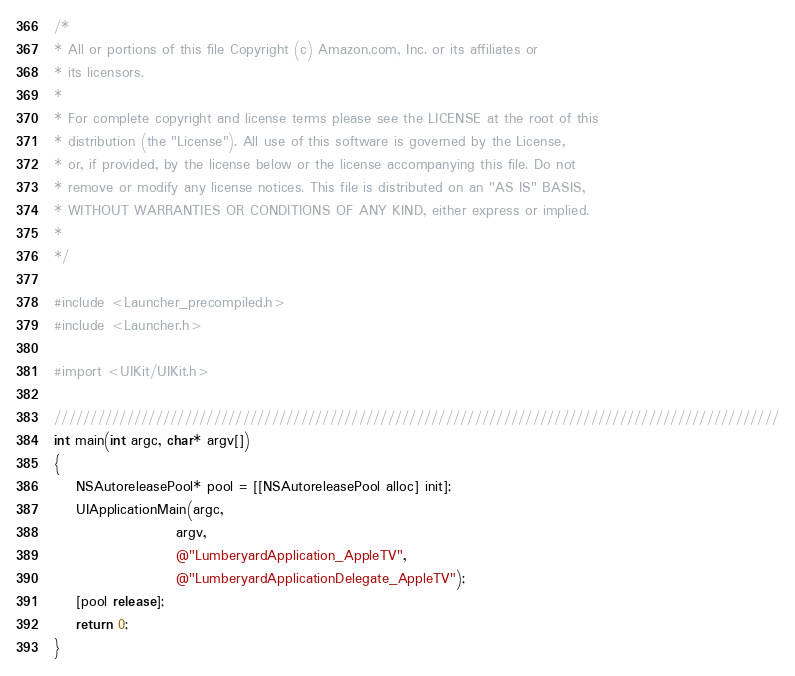<code> <loc_0><loc_0><loc_500><loc_500><_ObjectiveC_>/*
* All or portions of this file Copyright (c) Amazon.com, Inc. or its affiliates or
* its licensors.
*
* For complete copyright and license terms please see the LICENSE at the root of this
* distribution (the "License"). All use of this software is governed by the License,
* or, if provided, by the license below or the license accompanying this file. Do not
* remove or modify any license notices. This file is distributed on an "AS IS" BASIS,
* WITHOUT WARRANTIES OR CONDITIONS OF ANY KIND, either express or implied.
*
*/

#include <Launcher_precompiled.h>
#include <Launcher.h>

#import <UIKit/UIKit.h>

////////////////////////////////////////////////////////////////////////////////////////////////////
int main(int argc, char* argv[])
{
    NSAutoreleasePool* pool = [[NSAutoreleasePool alloc] init];
    UIApplicationMain(argc,
                      argv,
                      @"LumberyardApplication_AppleTV",
                      @"LumberyardApplicationDelegate_AppleTV");
    [pool release];
    return 0;
}
</code> 